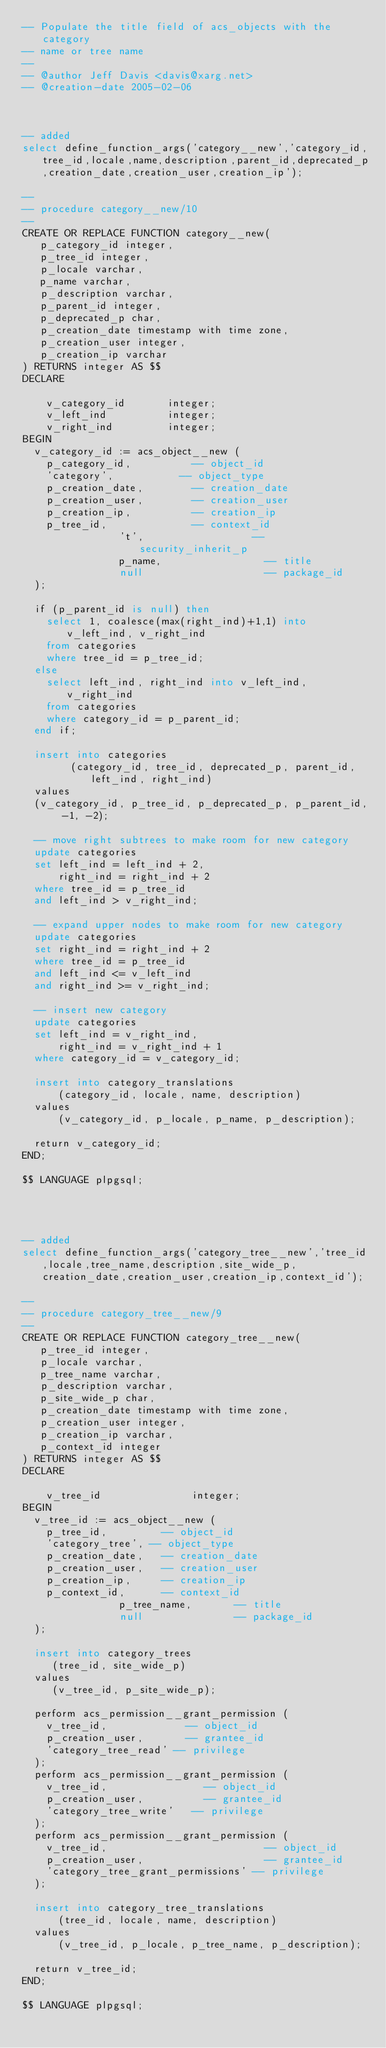Convert code to text. <code><loc_0><loc_0><loc_500><loc_500><_SQL_>-- Populate the title field of acs_objects with the category 
-- name or tree name
--
-- @author Jeff Davis <davis@xarg.net>
-- @creation-date 2005-02-06



-- added
select define_function_args('category__new','category_id,tree_id,locale,name,description,parent_id,deprecated_p,creation_date,creation_user,creation_ip');

--
-- procedure category__new/10
--
CREATE OR REPLACE FUNCTION category__new(
   p_category_id integer,
   p_tree_id integer,
   p_locale varchar,
   p_name varchar,
   p_description varchar,
   p_parent_id integer,
   p_deprecated_p char,
   p_creation_date timestamp with time zone,
   p_creation_user integer,
   p_creation_ip varchar
) RETURNS integer AS $$
DECLARE

    v_category_id       integer; 
    v_left_ind          integer;
    v_right_ind         integer;
BEGIN
	v_category_id := acs_object__new ( 
		p_category_id,          -- object_id
		'category',           -- object_type
		p_creation_date,        -- creation_date
		p_creation_user,        -- creation_user
		p_creation_ip,          -- creation_ip
		p_tree_id,              -- context_id
                't',                  -- security_inherit_p
                p_name,                 -- title
                null                    -- package_id
	);

	if (p_parent_id is null) then
		select 1, coalesce(max(right_ind)+1,1) into v_left_ind, v_right_ind
		from categories
		where tree_id = p_tree_id;
	else
		select left_ind, right_ind into v_left_ind, v_right_ind
		from categories
		where category_id = p_parent_id;
	end if;

 	insert into categories
        (category_id, tree_id, deprecated_p, parent_id, left_ind, right_ind)
	values
	(v_category_id, p_tree_id, p_deprecated_p, p_parent_id, -1, -2);

	-- move right subtrees to make room for new category
	update categories
	set left_ind = left_ind + 2,
	    right_ind = right_ind + 2
	where tree_id = p_tree_id
	and left_ind > v_right_ind;

	-- expand upper nodes to make room for new category
	update categories
	set right_ind = right_ind + 2
	where tree_id = p_tree_id
	and left_ind <= v_left_ind
	and right_ind >= v_right_ind;

	-- insert new category
	update categories
	set left_ind = v_right_ind,
	    right_ind = v_right_ind + 1
	where category_id = v_category_id;

	insert into category_translations
	    (category_id, locale, name, description)
	values
	    (v_category_id, p_locale, p_name, p_description);

	return v_category_id;
END;

$$ LANGUAGE plpgsql;




-- added
select define_function_args('category_tree__new','tree_id,locale,tree_name,description,site_wide_p,creation_date,creation_user,creation_ip,context_id');

--
-- procedure category_tree__new/9
--
CREATE OR REPLACE FUNCTION category_tree__new(
   p_tree_id integer,
   p_locale varchar,
   p_tree_name varchar,
   p_description varchar,
   p_site_wide_p char,
   p_creation_date timestamp with time zone,
   p_creation_user integer,
   p_creation_ip varchar,
   p_context_id integer
) RETURNS integer AS $$
DECLARE
  
    v_tree_id               integer;
BEGIN
	v_tree_id := acs_object__new (
		p_tree_id,         -- object_id
		'category_tree', -- object_type
		p_creation_date,   -- creation_date
		p_creation_user,   -- creation_user
		p_creation_ip,     -- creation_ip
		p_context_id,      -- context_id
                p_tree_name,       -- title
                null               -- package_id
	);

	insert into category_trees
	   (tree_id, site_wide_p)
	values
	   (v_tree_id, p_site_wide_p);

	perform acs_permission__grant_permission (
		v_tree_id,             -- object_id
		p_creation_user,       -- grantee_id
		'category_tree_read' -- privilege
	);
	perform acs_permission__grant_permission (
		v_tree_id,                -- object_id
		p_creation_user,          -- grantee_id
		'category_tree_write'   -- privilege
	);
	perform acs_permission__grant_permission (
		v_tree_id,                          -- object_id
		p_creation_user,                    -- grantee_id
		'category_tree_grant_permissions' -- privilege
	);

	insert into category_tree_translations
	    (tree_id, locale, name, description)
	values
	    (v_tree_id, p_locale, p_tree_name, p_description);

	return v_tree_id;
END;

$$ LANGUAGE plpgsql;

</code> 